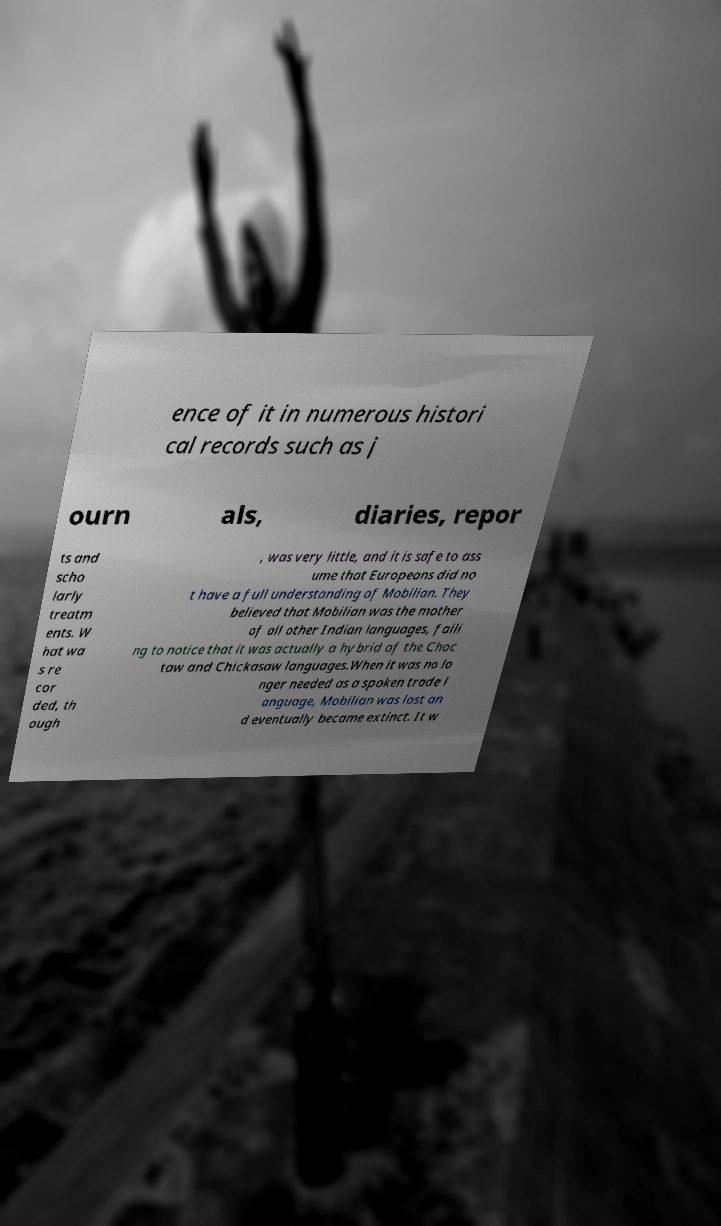Could you extract and type out the text from this image? ence of it in numerous histori cal records such as j ourn als, diaries, repor ts and scho larly treatm ents. W hat wa s re cor ded, th ough , was very little, and it is safe to ass ume that Europeans did no t have a full understanding of Mobilian. They believed that Mobilian was the mother of all other Indian languages, faili ng to notice that it was actually a hybrid of the Choc taw and Chickasaw languages.When it was no lo nger needed as a spoken trade l anguage, Mobilian was lost an d eventually became extinct. It w 